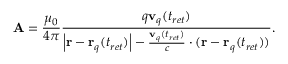<formula> <loc_0><loc_0><loc_500><loc_500>A = { \frac { \mu _ { 0 } } { 4 \pi } } { \frac { q v _ { q } ( t _ { r e t } ) } { \left | r - r _ { q } ( t _ { r e t } ) \right | - { \frac { v _ { q } ( t _ { r e t } ) } { c } } \cdot ( r - r _ { q } ( t _ { r e t } ) ) } } .</formula> 